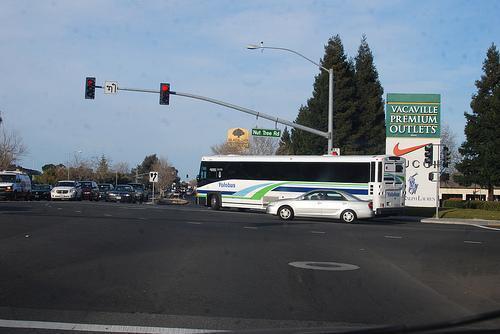How many signs are right of the bus?
Give a very brief answer. 2. 